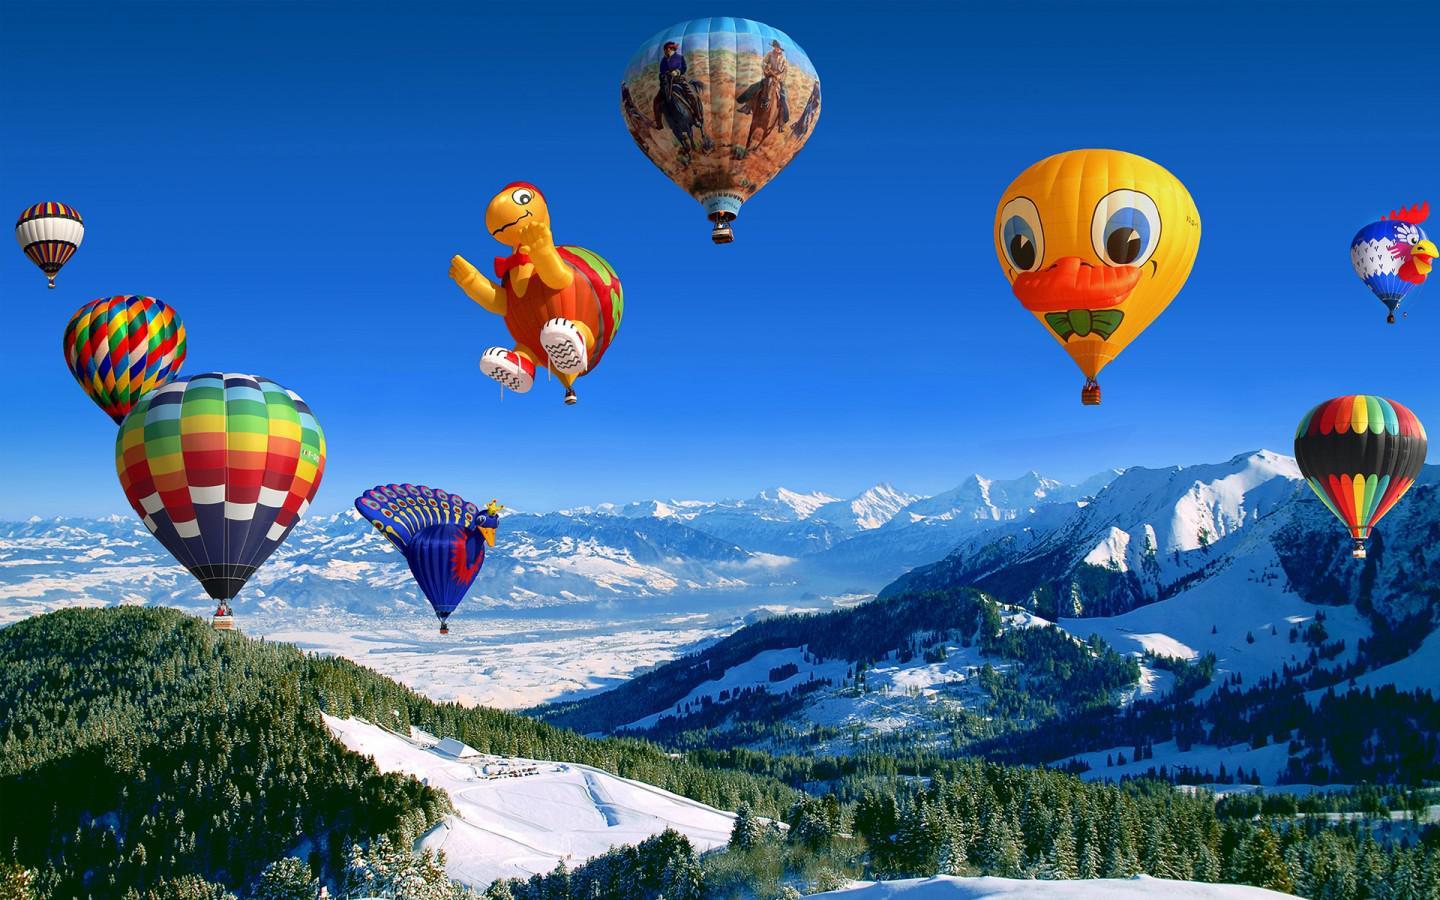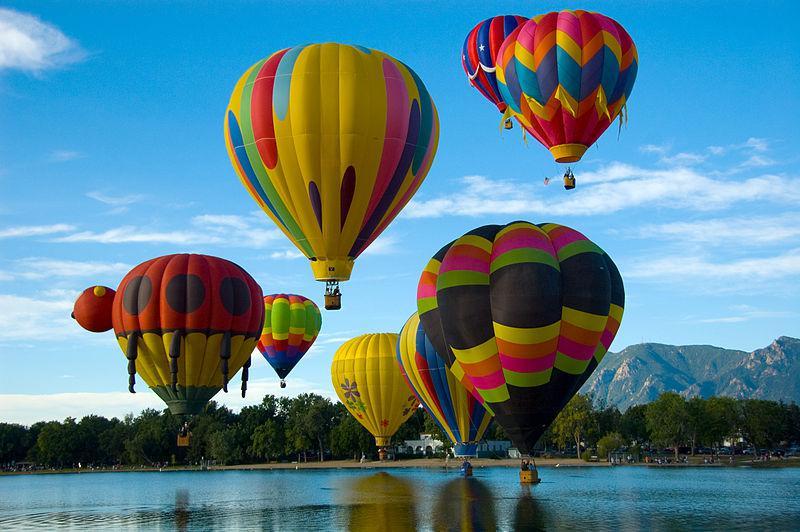The first image is the image on the left, the second image is the image on the right. For the images displayed, is the sentence "There are hot air balloons floating over a body of water in the right image." factually correct? Answer yes or no. Yes. The first image is the image on the left, the second image is the image on the right. Evaluate the accuracy of this statement regarding the images: "At least one balloon is shaped like an animal with legs.". Is it true? Answer yes or no. Yes. 